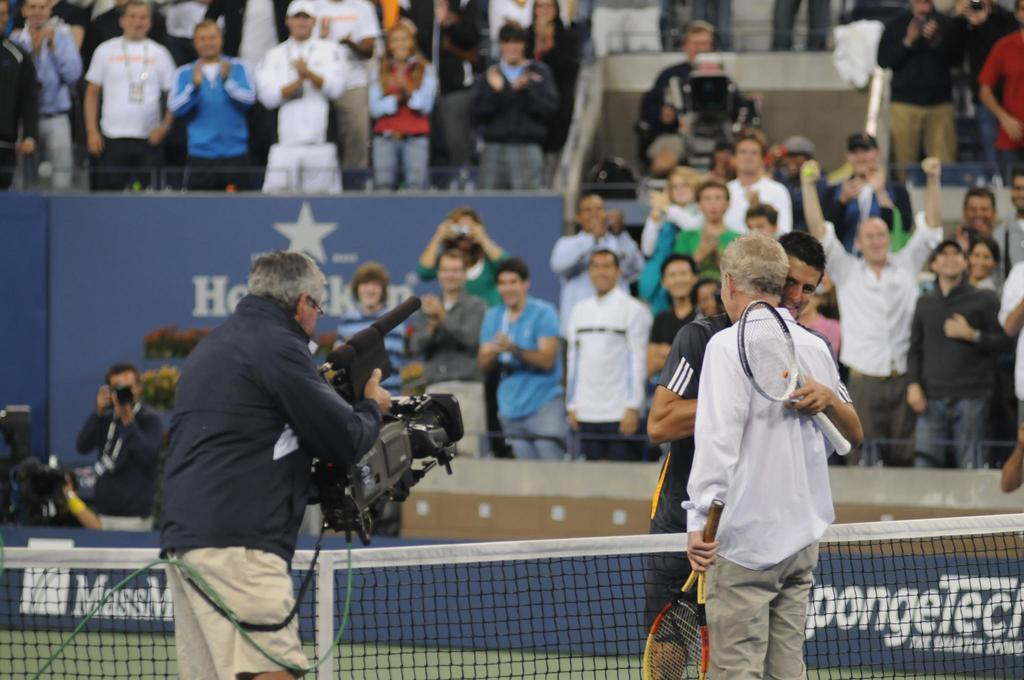<image>
Describe the image concisely. A cameraman with heavy gear records the scene in front of a Heineken ad, as a tennis player is congratulated. 